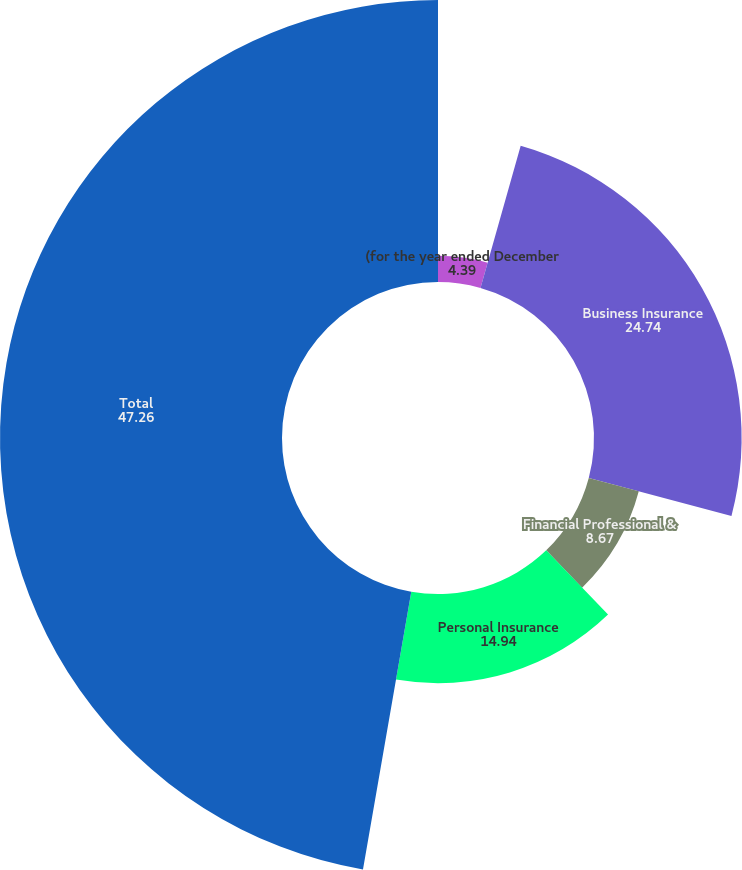Convert chart to OTSL. <chart><loc_0><loc_0><loc_500><loc_500><pie_chart><fcel>(for the year ended December<fcel>Business Insurance<fcel>Financial Professional &<fcel>Personal Insurance<fcel>Total<nl><fcel>4.39%<fcel>24.74%<fcel>8.67%<fcel>14.94%<fcel>47.26%<nl></chart> 